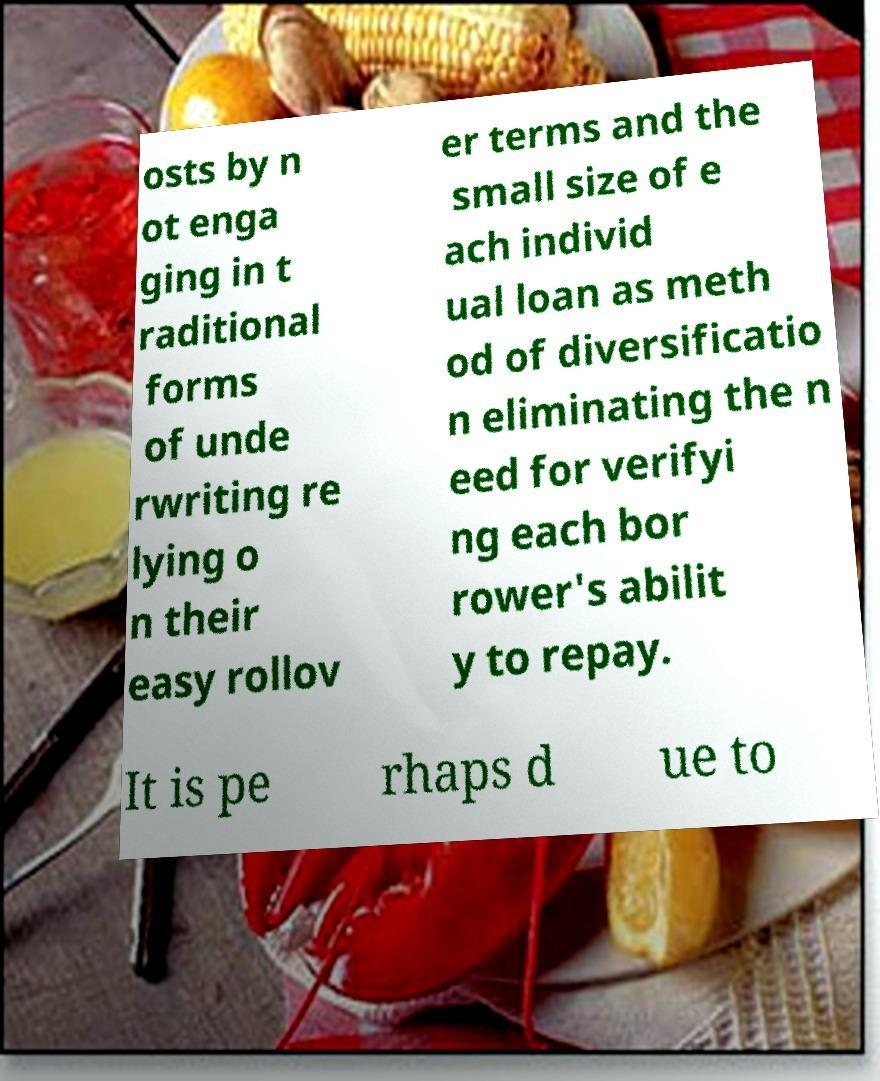For documentation purposes, I need the text within this image transcribed. Could you provide that? osts by n ot enga ging in t raditional forms of unde rwriting re lying o n their easy rollov er terms and the small size of e ach individ ual loan as meth od of diversificatio n eliminating the n eed for verifyi ng each bor rower's abilit y to repay. It is pe rhaps d ue to 